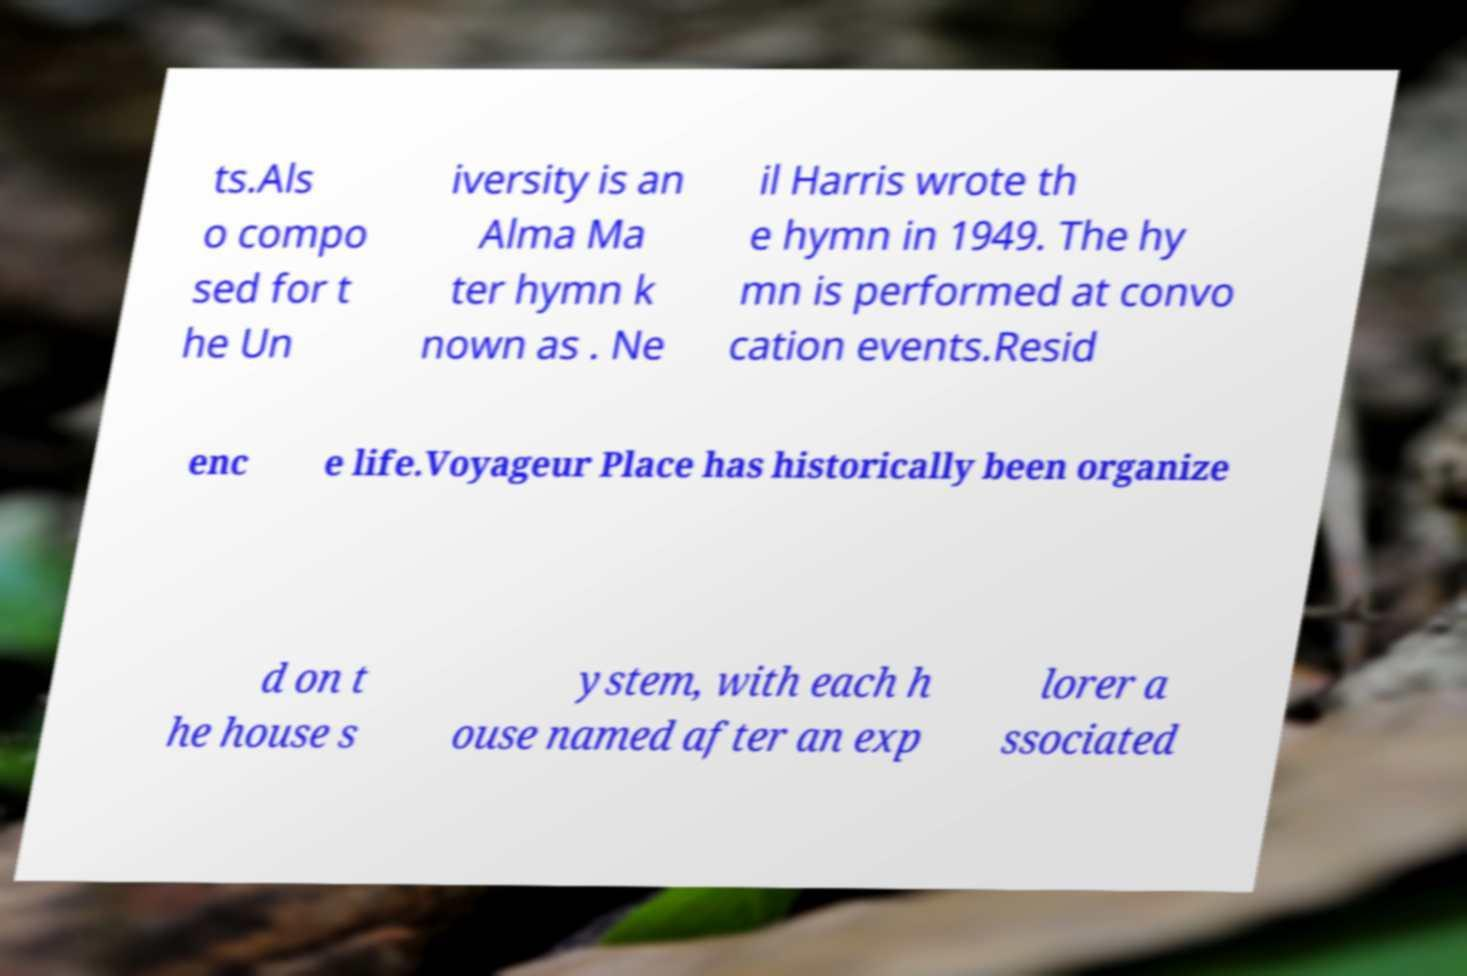What messages or text are displayed in this image? I need them in a readable, typed format. ts.Als o compo sed for t he Un iversity is an Alma Ma ter hymn k nown as . Ne il Harris wrote th e hymn in 1949. The hy mn is performed at convo cation events.Resid enc e life.Voyageur Place has historically been organize d on t he house s ystem, with each h ouse named after an exp lorer a ssociated 